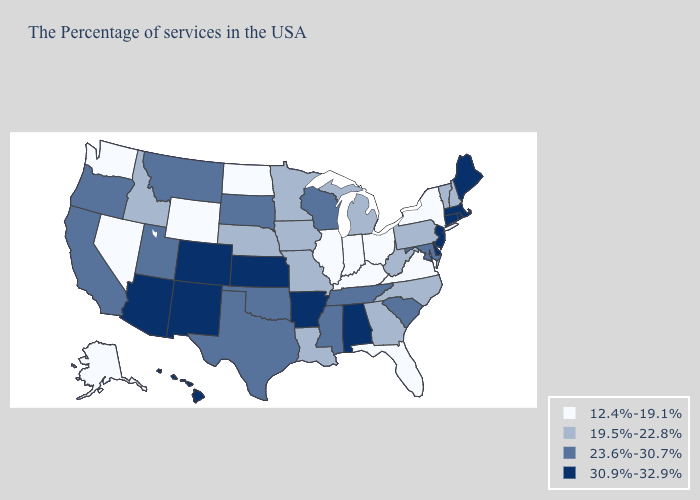Is the legend a continuous bar?
Short answer required. No. What is the lowest value in the South?
Concise answer only. 12.4%-19.1%. Is the legend a continuous bar?
Concise answer only. No. Does Maryland have the lowest value in the South?
Answer briefly. No. Among the states that border Iowa , does Illinois have the lowest value?
Short answer required. Yes. How many symbols are there in the legend?
Quick response, please. 4. What is the lowest value in the USA?
Concise answer only. 12.4%-19.1%. Does Ohio have the same value as Pennsylvania?
Concise answer only. No. What is the value of New Jersey?
Give a very brief answer. 30.9%-32.9%. Name the states that have a value in the range 30.9%-32.9%?
Be succinct. Maine, Massachusetts, Rhode Island, Connecticut, New Jersey, Delaware, Alabama, Arkansas, Kansas, Colorado, New Mexico, Arizona, Hawaii. How many symbols are there in the legend?
Be succinct. 4. What is the highest value in the USA?
Give a very brief answer. 30.9%-32.9%. Does New York have the lowest value in the Northeast?
Give a very brief answer. Yes. What is the value of Florida?
Give a very brief answer. 12.4%-19.1%. Is the legend a continuous bar?
Concise answer only. No. 